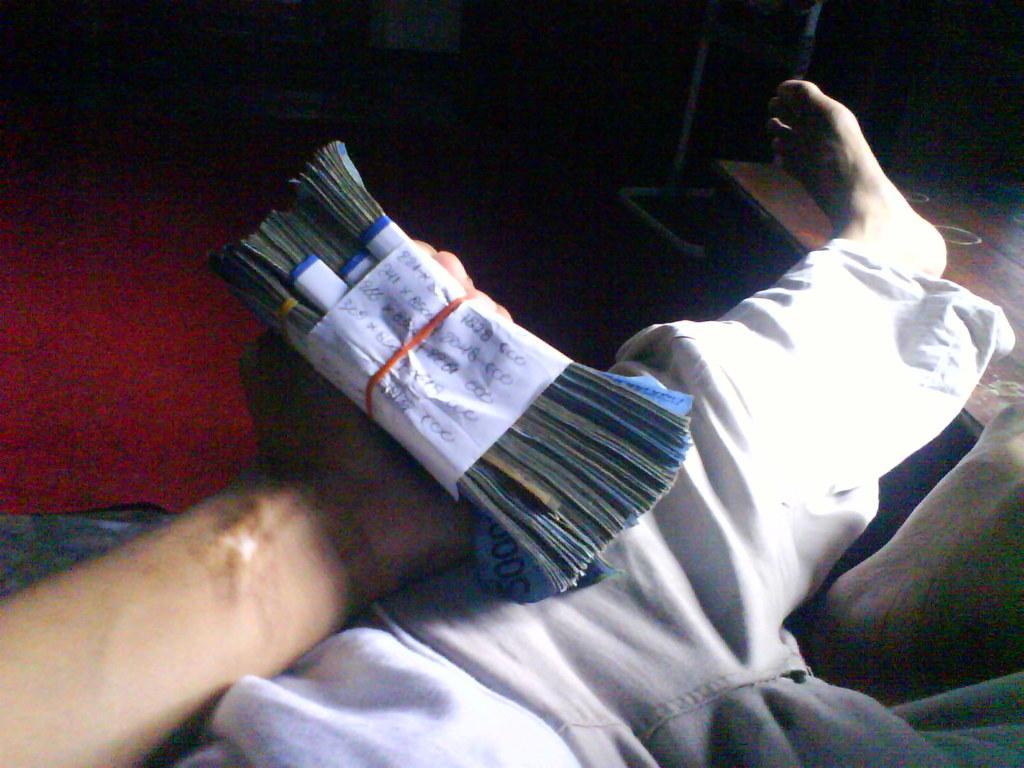Describe this image in one or two sentences. In this picture we can see a person holding a bundles of currency notes with hand and in the background we can see a red carpet, table, stand and it is dark. 